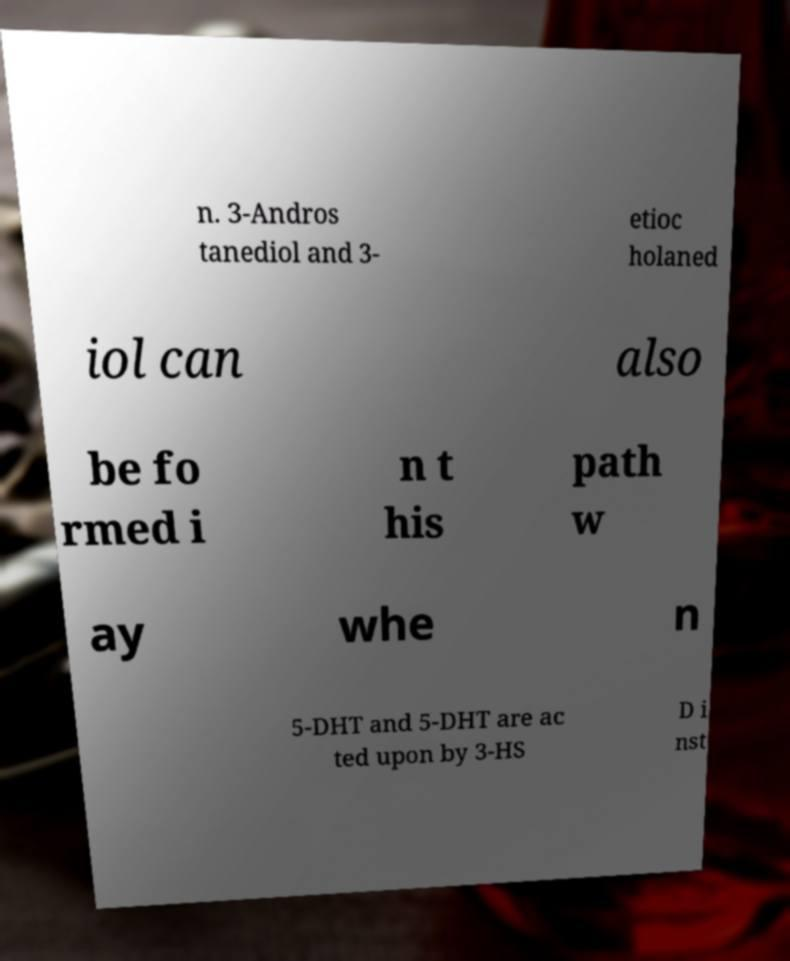I need the written content from this picture converted into text. Can you do that? n. 3-Andros tanediol and 3- etioc holaned iol can also be fo rmed i n t his path w ay whe n 5-DHT and 5-DHT are ac ted upon by 3-HS D i nst 